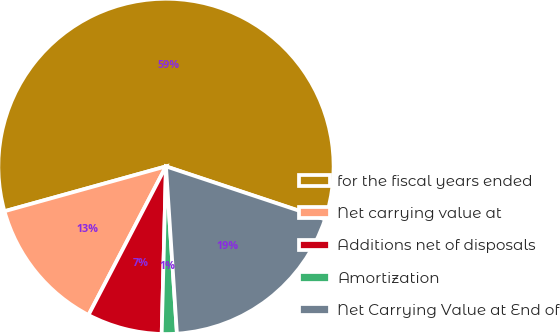Convert chart to OTSL. <chart><loc_0><loc_0><loc_500><loc_500><pie_chart><fcel>for the fiscal years ended<fcel>Net carrying value at<fcel>Additions net of disposals<fcel>Amortization<fcel>Net Carrying Value at End of<nl><fcel>59.43%<fcel>13.04%<fcel>7.24%<fcel>1.45%<fcel>18.84%<nl></chart> 